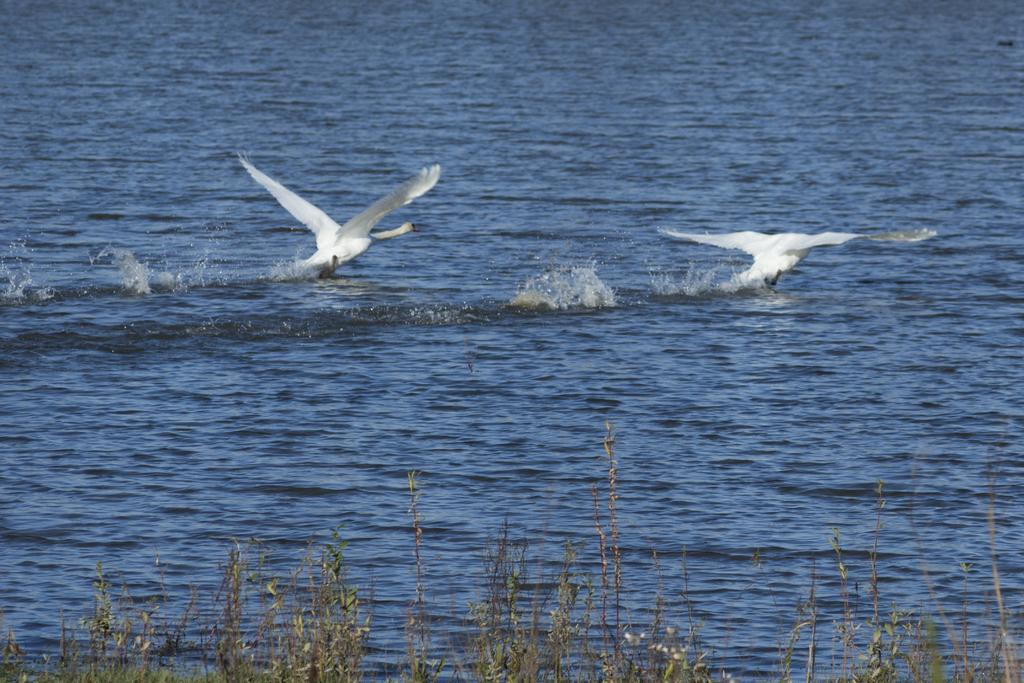What is visible in the image? There is water visible in the image. What is happening in the sky in the image? There are two birds flying over the surface of the water. What can be seen at the bottom of the image? There are plants at the bottom of the image. What type of machine can be seen operating in the water in the image? There is no machine present in the image; it features water, birds, and plants. Can you tell me which bird is winning the chess game in the image? There is no chess game present in the image; it features birds flying over the water. 